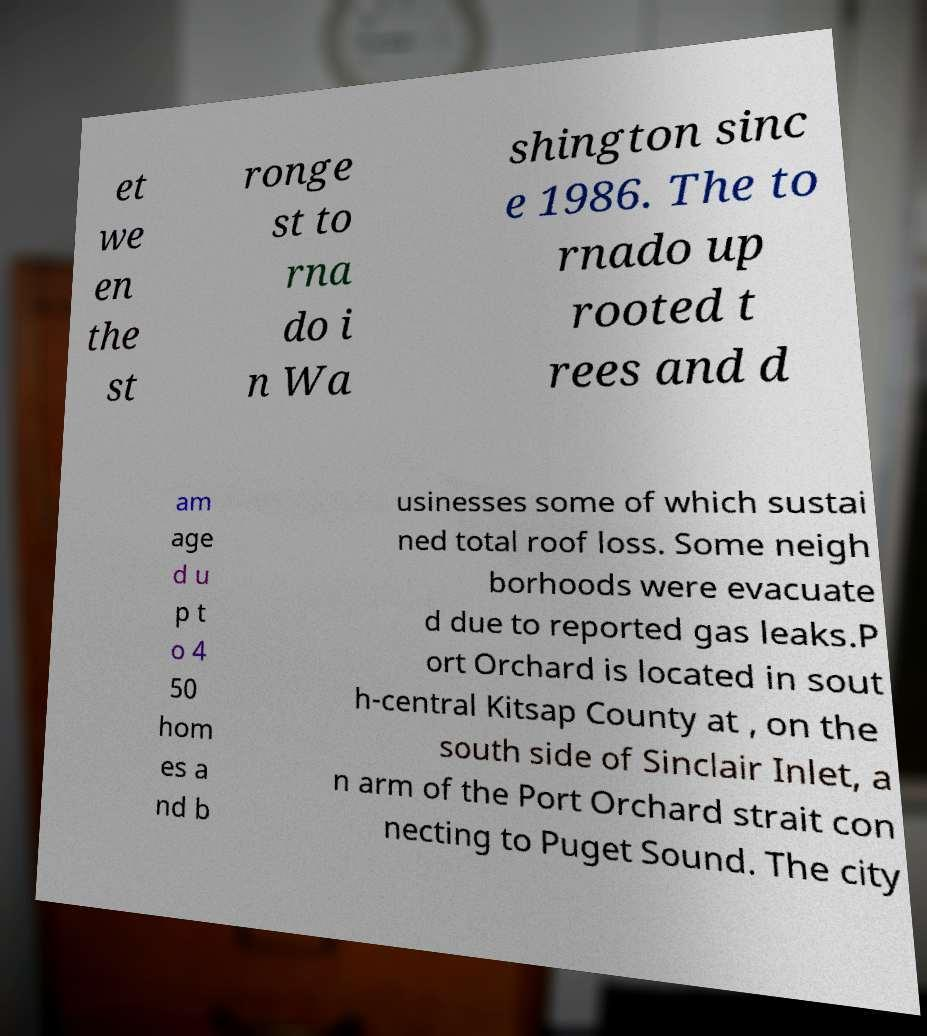I need the written content from this picture converted into text. Can you do that? et we en the st ronge st to rna do i n Wa shington sinc e 1986. The to rnado up rooted t rees and d am age d u p t o 4 50 hom es a nd b usinesses some of which sustai ned total roof loss. Some neigh borhoods were evacuate d due to reported gas leaks.P ort Orchard is located in sout h-central Kitsap County at , on the south side of Sinclair Inlet, a n arm of the Port Orchard strait con necting to Puget Sound. The city 